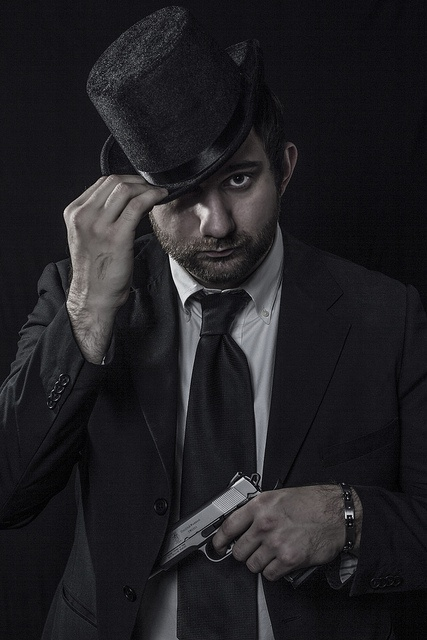Describe the objects in this image and their specific colors. I can see people in black, gray, and darkgray tones and tie in black and gray tones in this image. 